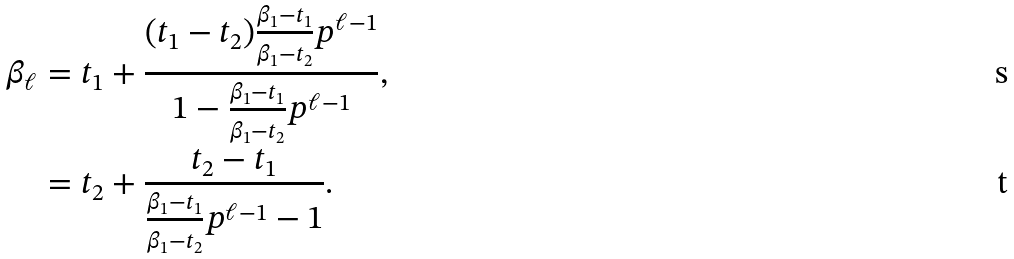Convert formula to latex. <formula><loc_0><loc_0><loc_500><loc_500>\beta _ { \ell } & = t _ { 1 } + \frac { ( t _ { 1 } - t _ { 2 } ) \frac { \beta _ { 1 } - t _ { 1 } } { \beta _ { 1 } - t _ { 2 } } p ^ { \ell - 1 } } { 1 - \frac { \beta _ { 1 } - t _ { 1 } } { \beta _ { 1 } - t _ { 2 } } p ^ { \ell - 1 } } , \\ & = t _ { 2 } + \frac { t _ { 2 } - t _ { 1 } } { \frac { \beta _ { 1 } - t _ { 1 } } { \beta _ { 1 } - t _ { 2 } } p ^ { \ell - 1 } - 1 } .</formula> 